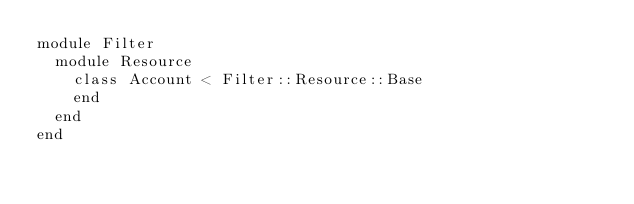<code> <loc_0><loc_0><loc_500><loc_500><_Ruby_>module Filter
  module Resource
    class Account < Filter::Resource::Base
    end
  end
end
</code> 